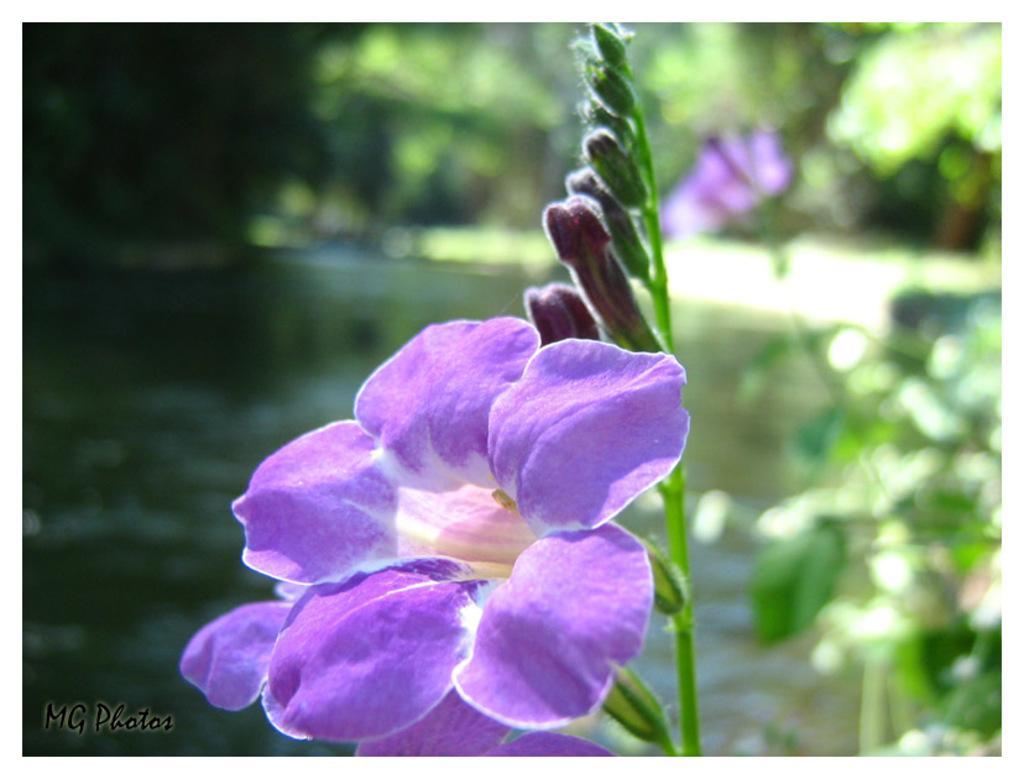What is the main subject in the foreground of the image? There is a flower in the foreground of the image. Can you describe the background of the image? The background of the image is blurry. What type of error message is displayed in the image? There is no error message present in the image; it features a flower in the foreground and a blurry background. Can you tell me how many chairs are visible in the image? There are no chairs present in the image. 